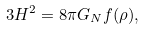Convert formula to latex. <formula><loc_0><loc_0><loc_500><loc_500>3 H ^ { 2 } = 8 \pi G _ { N } f ( \rho ) ,</formula> 